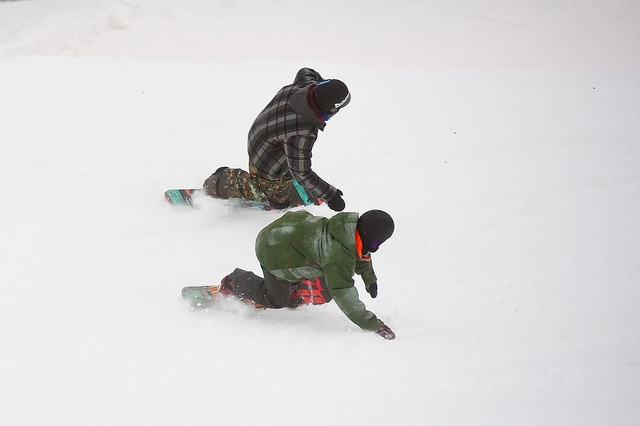Describe the objects in this image and their specific colors. I can see people in darkgray, gray, darkgreen, and black tones, people in darkgray, black, and gray tones, snowboard in darkgray and lightgray tones, and snowboard in darkgray, gray, teal, and lightgray tones in this image. 